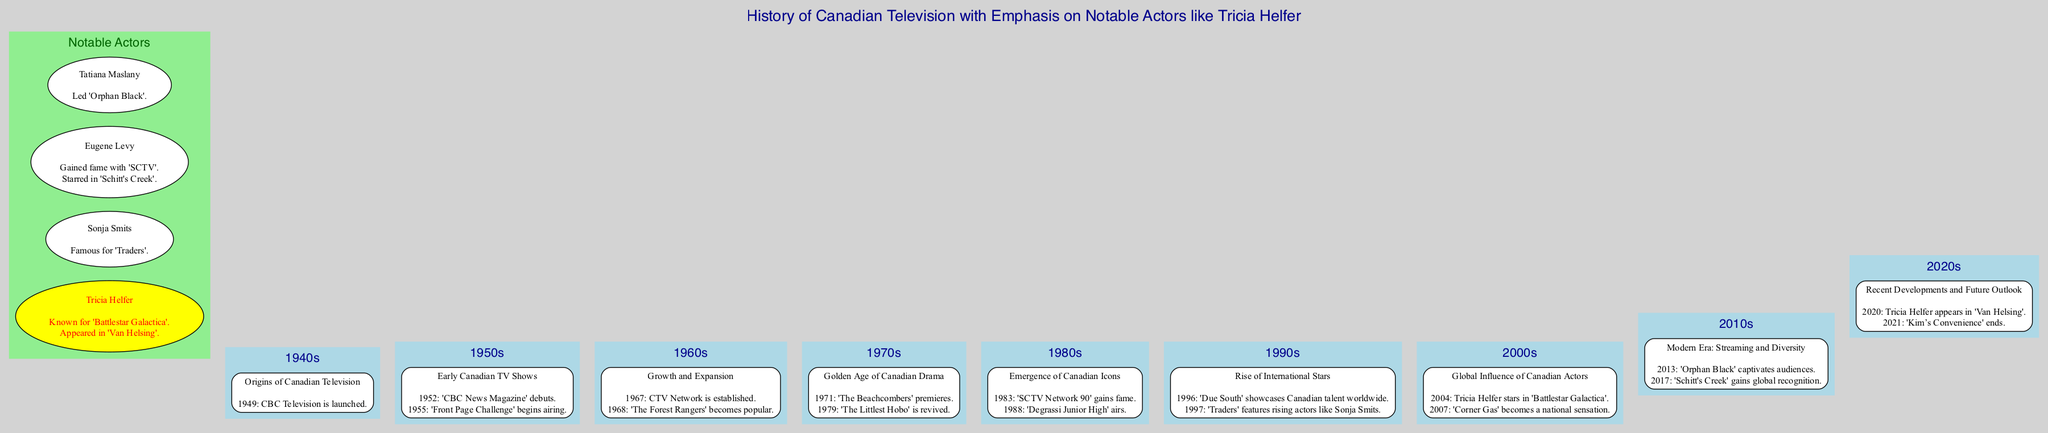What year did CBC Television launch? The diagram indicates that CBC Television was launched in 1949, which is clearly stated in the key events for the 1940s.
Answer: 1949 Which notable actor starred in 'Battlestar Galactica'? The diagram specifies that Tricia Helfer is known for her role in 'Battlestar Galactica', which is highlighted in the actors section.
Answer: Tricia Helfer How many decades are represented in the timeline? The diagram shows entries for each decade from the 1940s to the 2020s, totaling eight distinct decades.
Answer: 8 What significant event occurred in 1983? According to the key events listed for the 1980s, 'SCTV Network 90' gained fame in 1983. This specific event is noted clearly in the diagram.
Answer: 'SCTV Network 90' gains fame What was a key event in the 2000s related to Tricia Helfer? The timeline indicates that Tricia Helfer starred in 'Battlestar Galactica' in 2004, marking a significant event for that decade related to her career.
Answer: Tricia Helfer stars in 'Battlestar Galactica' Which actor is associated with 'Schitt's Creek'? The diagram lists Eugene Levy as a notable actor who starred in 'Schitt's Creek', as noted in his highlights.
Answer: Eugene Levy What is the focus of the 1970s on the timeline? The description for the 1970s in the diagram mentions it as the "Golden Age of Canadian Drama," indicating the overall theme for that decade.
Answer: Golden Age of Canadian Drama Which decade saw the premiere of 'The Beachcombers'? The key event for the 1970s specifies that 'The Beachcombers' premiered in 1971, which identifies its placement in that decade.
Answer: 1970s What notable change happened in 1967? The diagram identifies the establishment of the CTV Network in 1967 as a significant event in the growth and expansion phase of Canadian television in the 1960s.
Answer: CTV Network is established 